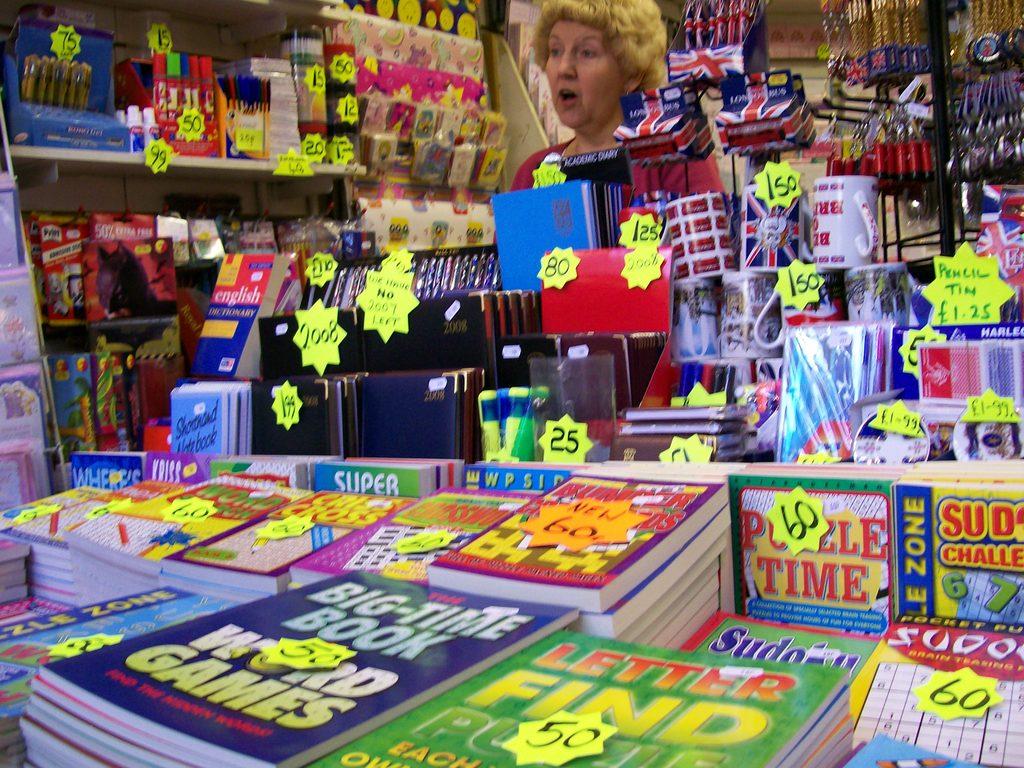How much is puzzle time?
Your answer should be compact. 60. Is there a book on word games?
Your response must be concise. Yes. 